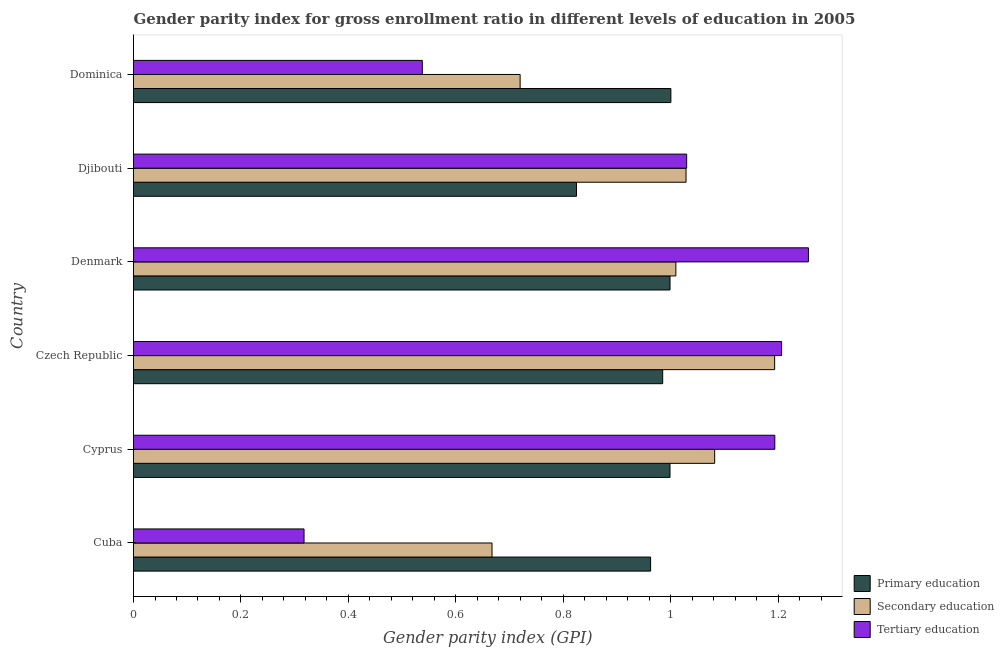How many groups of bars are there?
Make the answer very short. 6. Are the number of bars per tick equal to the number of legend labels?
Ensure brevity in your answer.  Yes. How many bars are there on the 2nd tick from the bottom?
Give a very brief answer. 3. What is the label of the 6th group of bars from the top?
Keep it short and to the point. Cuba. In how many cases, is the number of bars for a given country not equal to the number of legend labels?
Your answer should be very brief. 0. What is the gender parity index in tertiary education in Cyprus?
Provide a succinct answer. 1.19. Across all countries, what is the maximum gender parity index in tertiary education?
Your response must be concise. 1.26. Across all countries, what is the minimum gender parity index in tertiary education?
Ensure brevity in your answer.  0.32. In which country was the gender parity index in tertiary education minimum?
Provide a succinct answer. Cuba. What is the total gender parity index in tertiary education in the graph?
Ensure brevity in your answer.  5.54. What is the difference between the gender parity index in tertiary education in Czech Republic and that in Djibouti?
Your answer should be compact. 0.18. What is the difference between the gender parity index in primary education in Cuba and the gender parity index in tertiary education in Denmark?
Your answer should be very brief. -0.29. What is the difference between the gender parity index in tertiary education and gender parity index in primary education in Cuba?
Give a very brief answer. -0.65. In how many countries, is the gender parity index in primary education greater than 0.68 ?
Offer a very short reply. 6. What is the ratio of the gender parity index in tertiary education in Djibouti to that in Dominica?
Give a very brief answer. 1.92. Is the gender parity index in tertiary education in Denmark less than that in Djibouti?
Offer a very short reply. No. Is the difference between the gender parity index in primary education in Czech Republic and Denmark greater than the difference between the gender parity index in tertiary education in Czech Republic and Denmark?
Your response must be concise. Yes. What is the difference between the highest and the second highest gender parity index in secondary education?
Give a very brief answer. 0.11. What is the difference between the highest and the lowest gender parity index in primary education?
Offer a terse response. 0.18. In how many countries, is the gender parity index in tertiary education greater than the average gender parity index in tertiary education taken over all countries?
Make the answer very short. 4. Is the sum of the gender parity index in tertiary education in Czech Republic and Djibouti greater than the maximum gender parity index in secondary education across all countries?
Your response must be concise. Yes. What does the 1st bar from the top in Cuba represents?
Your response must be concise. Tertiary education. What does the 3rd bar from the bottom in Denmark represents?
Give a very brief answer. Tertiary education. Is it the case that in every country, the sum of the gender parity index in primary education and gender parity index in secondary education is greater than the gender parity index in tertiary education?
Your answer should be compact. Yes. Are all the bars in the graph horizontal?
Your response must be concise. Yes. Are the values on the major ticks of X-axis written in scientific E-notation?
Provide a succinct answer. No. Does the graph contain any zero values?
Ensure brevity in your answer.  No. How are the legend labels stacked?
Provide a succinct answer. Vertical. What is the title of the graph?
Your response must be concise. Gender parity index for gross enrollment ratio in different levels of education in 2005. What is the label or title of the X-axis?
Offer a very short reply. Gender parity index (GPI). What is the label or title of the Y-axis?
Offer a terse response. Country. What is the Gender parity index (GPI) of Primary education in Cuba?
Offer a very short reply. 0.96. What is the Gender parity index (GPI) in Secondary education in Cuba?
Ensure brevity in your answer.  0.67. What is the Gender parity index (GPI) in Tertiary education in Cuba?
Ensure brevity in your answer.  0.32. What is the Gender parity index (GPI) of Primary education in Cyprus?
Provide a succinct answer. 1. What is the Gender parity index (GPI) of Secondary education in Cyprus?
Your answer should be compact. 1.08. What is the Gender parity index (GPI) of Tertiary education in Cyprus?
Provide a short and direct response. 1.19. What is the Gender parity index (GPI) in Primary education in Czech Republic?
Provide a succinct answer. 0.99. What is the Gender parity index (GPI) in Secondary education in Czech Republic?
Keep it short and to the point. 1.19. What is the Gender parity index (GPI) in Tertiary education in Czech Republic?
Your answer should be very brief. 1.21. What is the Gender parity index (GPI) of Primary education in Denmark?
Your response must be concise. 1. What is the Gender parity index (GPI) of Secondary education in Denmark?
Your response must be concise. 1.01. What is the Gender parity index (GPI) in Tertiary education in Denmark?
Keep it short and to the point. 1.26. What is the Gender parity index (GPI) of Primary education in Djibouti?
Your response must be concise. 0.82. What is the Gender parity index (GPI) in Secondary education in Djibouti?
Give a very brief answer. 1.03. What is the Gender parity index (GPI) of Tertiary education in Djibouti?
Your answer should be compact. 1.03. What is the Gender parity index (GPI) of Primary education in Dominica?
Your response must be concise. 1. What is the Gender parity index (GPI) in Secondary education in Dominica?
Offer a terse response. 0.72. What is the Gender parity index (GPI) of Tertiary education in Dominica?
Offer a terse response. 0.54. Across all countries, what is the maximum Gender parity index (GPI) of Primary education?
Offer a very short reply. 1. Across all countries, what is the maximum Gender parity index (GPI) in Secondary education?
Your answer should be very brief. 1.19. Across all countries, what is the maximum Gender parity index (GPI) in Tertiary education?
Your answer should be compact. 1.26. Across all countries, what is the minimum Gender parity index (GPI) of Primary education?
Your answer should be very brief. 0.82. Across all countries, what is the minimum Gender parity index (GPI) of Secondary education?
Provide a short and direct response. 0.67. Across all countries, what is the minimum Gender parity index (GPI) in Tertiary education?
Offer a terse response. 0.32. What is the total Gender parity index (GPI) in Primary education in the graph?
Your response must be concise. 5.77. What is the total Gender parity index (GPI) of Secondary education in the graph?
Keep it short and to the point. 5.7. What is the total Gender parity index (GPI) in Tertiary education in the graph?
Give a very brief answer. 5.54. What is the difference between the Gender parity index (GPI) of Primary education in Cuba and that in Cyprus?
Provide a short and direct response. -0.04. What is the difference between the Gender parity index (GPI) in Secondary education in Cuba and that in Cyprus?
Offer a terse response. -0.41. What is the difference between the Gender parity index (GPI) of Tertiary education in Cuba and that in Cyprus?
Your answer should be compact. -0.88. What is the difference between the Gender parity index (GPI) of Primary education in Cuba and that in Czech Republic?
Provide a short and direct response. -0.02. What is the difference between the Gender parity index (GPI) of Secondary education in Cuba and that in Czech Republic?
Make the answer very short. -0.53. What is the difference between the Gender parity index (GPI) in Tertiary education in Cuba and that in Czech Republic?
Keep it short and to the point. -0.89. What is the difference between the Gender parity index (GPI) in Primary education in Cuba and that in Denmark?
Offer a terse response. -0.04. What is the difference between the Gender parity index (GPI) of Secondary education in Cuba and that in Denmark?
Your response must be concise. -0.34. What is the difference between the Gender parity index (GPI) of Tertiary education in Cuba and that in Denmark?
Provide a succinct answer. -0.94. What is the difference between the Gender parity index (GPI) of Primary education in Cuba and that in Djibouti?
Give a very brief answer. 0.14. What is the difference between the Gender parity index (GPI) of Secondary education in Cuba and that in Djibouti?
Offer a terse response. -0.36. What is the difference between the Gender parity index (GPI) of Tertiary education in Cuba and that in Djibouti?
Ensure brevity in your answer.  -0.71. What is the difference between the Gender parity index (GPI) in Primary education in Cuba and that in Dominica?
Keep it short and to the point. -0.04. What is the difference between the Gender parity index (GPI) in Secondary education in Cuba and that in Dominica?
Your answer should be very brief. -0.05. What is the difference between the Gender parity index (GPI) in Tertiary education in Cuba and that in Dominica?
Offer a terse response. -0.22. What is the difference between the Gender parity index (GPI) of Primary education in Cyprus and that in Czech Republic?
Make the answer very short. 0.01. What is the difference between the Gender parity index (GPI) of Secondary education in Cyprus and that in Czech Republic?
Make the answer very short. -0.11. What is the difference between the Gender parity index (GPI) of Tertiary education in Cyprus and that in Czech Republic?
Keep it short and to the point. -0.01. What is the difference between the Gender parity index (GPI) of Primary education in Cyprus and that in Denmark?
Ensure brevity in your answer.  -0. What is the difference between the Gender parity index (GPI) in Secondary education in Cyprus and that in Denmark?
Offer a very short reply. 0.07. What is the difference between the Gender parity index (GPI) of Tertiary education in Cyprus and that in Denmark?
Your answer should be very brief. -0.06. What is the difference between the Gender parity index (GPI) in Primary education in Cyprus and that in Djibouti?
Your response must be concise. 0.17. What is the difference between the Gender parity index (GPI) in Secondary education in Cyprus and that in Djibouti?
Keep it short and to the point. 0.05. What is the difference between the Gender parity index (GPI) of Tertiary education in Cyprus and that in Djibouti?
Offer a terse response. 0.16. What is the difference between the Gender parity index (GPI) in Primary education in Cyprus and that in Dominica?
Your answer should be very brief. -0. What is the difference between the Gender parity index (GPI) of Secondary education in Cyprus and that in Dominica?
Ensure brevity in your answer.  0.36. What is the difference between the Gender parity index (GPI) of Tertiary education in Cyprus and that in Dominica?
Give a very brief answer. 0.66. What is the difference between the Gender parity index (GPI) of Primary education in Czech Republic and that in Denmark?
Ensure brevity in your answer.  -0.01. What is the difference between the Gender parity index (GPI) in Secondary education in Czech Republic and that in Denmark?
Ensure brevity in your answer.  0.18. What is the difference between the Gender parity index (GPI) in Tertiary education in Czech Republic and that in Denmark?
Give a very brief answer. -0.05. What is the difference between the Gender parity index (GPI) of Primary education in Czech Republic and that in Djibouti?
Ensure brevity in your answer.  0.16. What is the difference between the Gender parity index (GPI) in Secondary education in Czech Republic and that in Djibouti?
Provide a succinct answer. 0.17. What is the difference between the Gender parity index (GPI) of Tertiary education in Czech Republic and that in Djibouti?
Your answer should be compact. 0.18. What is the difference between the Gender parity index (GPI) in Primary education in Czech Republic and that in Dominica?
Ensure brevity in your answer.  -0.02. What is the difference between the Gender parity index (GPI) of Secondary education in Czech Republic and that in Dominica?
Your answer should be compact. 0.47. What is the difference between the Gender parity index (GPI) of Tertiary education in Czech Republic and that in Dominica?
Your answer should be compact. 0.67. What is the difference between the Gender parity index (GPI) in Primary education in Denmark and that in Djibouti?
Your answer should be very brief. 0.17. What is the difference between the Gender parity index (GPI) in Secondary education in Denmark and that in Djibouti?
Provide a short and direct response. -0.02. What is the difference between the Gender parity index (GPI) in Tertiary education in Denmark and that in Djibouti?
Give a very brief answer. 0.23. What is the difference between the Gender parity index (GPI) in Primary education in Denmark and that in Dominica?
Provide a short and direct response. -0. What is the difference between the Gender parity index (GPI) of Secondary education in Denmark and that in Dominica?
Offer a very short reply. 0.29. What is the difference between the Gender parity index (GPI) in Tertiary education in Denmark and that in Dominica?
Offer a terse response. 0.72. What is the difference between the Gender parity index (GPI) of Primary education in Djibouti and that in Dominica?
Provide a short and direct response. -0.18. What is the difference between the Gender parity index (GPI) in Secondary education in Djibouti and that in Dominica?
Offer a very short reply. 0.31. What is the difference between the Gender parity index (GPI) in Tertiary education in Djibouti and that in Dominica?
Offer a very short reply. 0.49. What is the difference between the Gender parity index (GPI) of Primary education in Cuba and the Gender parity index (GPI) of Secondary education in Cyprus?
Offer a very short reply. -0.12. What is the difference between the Gender parity index (GPI) of Primary education in Cuba and the Gender parity index (GPI) of Tertiary education in Cyprus?
Keep it short and to the point. -0.23. What is the difference between the Gender parity index (GPI) in Secondary education in Cuba and the Gender parity index (GPI) in Tertiary education in Cyprus?
Your answer should be very brief. -0.53. What is the difference between the Gender parity index (GPI) of Primary education in Cuba and the Gender parity index (GPI) of Secondary education in Czech Republic?
Provide a succinct answer. -0.23. What is the difference between the Gender parity index (GPI) in Primary education in Cuba and the Gender parity index (GPI) in Tertiary education in Czech Republic?
Give a very brief answer. -0.24. What is the difference between the Gender parity index (GPI) in Secondary education in Cuba and the Gender parity index (GPI) in Tertiary education in Czech Republic?
Keep it short and to the point. -0.54. What is the difference between the Gender parity index (GPI) of Primary education in Cuba and the Gender parity index (GPI) of Secondary education in Denmark?
Make the answer very short. -0.05. What is the difference between the Gender parity index (GPI) of Primary education in Cuba and the Gender parity index (GPI) of Tertiary education in Denmark?
Give a very brief answer. -0.29. What is the difference between the Gender parity index (GPI) in Secondary education in Cuba and the Gender parity index (GPI) in Tertiary education in Denmark?
Ensure brevity in your answer.  -0.59. What is the difference between the Gender parity index (GPI) in Primary education in Cuba and the Gender parity index (GPI) in Secondary education in Djibouti?
Give a very brief answer. -0.07. What is the difference between the Gender parity index (GPI) of Primary education in Cuba and the Gender parity index (GPI) of Tertiary education in Djibouti?
Keep it short and to the point. -0.07. What is the difference between the Gender parity index (GPI) in Secondary education in Cuba and the Gender parity index (GPI) in Tertiary education in Djibouti?
Keep it short and to the point. -0.36. What is the difference between the Gender parity index (GPI) of Primary education in Cuba and the Gender parity index (GPI) of Secondary education in Dominica?
Provide a succinct answer. 0.24. What is the difference between the Gender parity index (GPI) in Primary education in Cuba and the Gender parity index (GPI) in Tertiary education in Dominica?
Your answer should be very brief. 0.42. What is the difference between the Gender parity index (GPI) of Secondary education in Cuba and the Gender parity index (GPI) of Tertiary education in Dominica?
Offer a terse response. 0.13. What is the difference between the Gender parity index (GPI) in Primary education in Cyprus and the Gender parity index (GPI) in Secondary education in Czech Republic?
Give a very brief answer. -0.19. What is the difference between the Gender parity index (GPI) of Primary education in Cyprus and the Gender parity index (GPI) of Tertiary education in Czech Republic?
Your answer should be very brief. -0.21. What is the difference between the Gender parity index (GPI) in Secondary education in Cyprus and the Gender parity index (GPI) in Tertiary education in Czech Republic?
Keep it short and to the point. -0.12. What is the difference between the Gender parity index (GPI) in Primary education in Cyprus and the Gender parity index (GPI) in Secondary education in Denmark?
Offer a terse response. -0.01. What is the difference between the Gender parity index (GPI) of Primary education in Cyprus and the Gender parity index (GPI) of Tertiary education in Denmark?
Your answer should be very brief. -0.26. What is the difference between the Gender parity index (GPI) in Secondary education in Cyprus and the Gender parity index (GPI) in Tertiary education in Denmark?
Your answer should be very brief. -0.17. What is the difference between the Gender parity index (GPI) in Primary education in Cyprus and the Gender parity index (GPI) in Secondary education in Djibouti?
Your answer should be very brief. -0.03. What is the difference between the Gender parity index (GPI) of Primary education in Cyprus and the Gender parity index (GPI) of Tertiary education in Djibouti?
Offer a very short reply. -0.03. What is the difference between the Gender parity index (GPI) of Secondary education in Cyprus and the Gender parity index (GPI) of Tertiary education in Djibouti?
Keep it short and to the point. 0.05. What is the difference between the Gender parity index (GPI) of Primary education in Cyprus and the Gender parity index (GPI) of Secondary education in Dominica?
Make the answer very short. 0.28. What is the difference between the Gender parity index (GPI) of Primary education in Cyprus and the Gender parity index (GPI) of Tertiary education in Dominica?
Make the answer very short. 0.46. What is the difference between the Gender parity index (GPI) of Secondary education in Cyprus and the Gender parity index (GPI) of Tertiary education in Dominica?
Your answer should be compact. 0.54. What is the difference between the Gender parity index (GPI) in Primary education in Czech Republic and the Gender parity index (GPI) in Secondary education in Denmark?
Make the answer very short. -0.02. What is the difference between the Gender parity index (GPI) in Primary education in Czech Republic and the Gender parity index (GPI) in Tertiary education in Denmark?
Provide a succinct answer. -0.27. What is the difference between the Gender parity index (GPI) in Secondary education in Czech Republic and the Gender parity index (GPI) in Tertiary education in Denmark?
Offer a very short reply. -0.06. What is the difference between the Gender parity index (GPI) of Primary education in Czech Republic and the Gender parity index (GPI) of Secondary education in Djibouti?
Your answer should be very brief. -0.04. What is the difference between the Gender parity index (GPI) of Primary education in Czech Republic and the Gender parity index (GPI) of Tertiary education in Djibouti?
Provide a succinct answer. -0.04. What is the difference between the Gender parity index (GPI) in Secondary education in Czech Republic and the Gender parity index (GPI) in Tertiary education in Djibouti?
Provide a succinct answer. 0.16. What is the difference between the Gender parity index (GPI) of Primary education in Czech Republic and the Gender parity index (GPI) of Secondary education in Dominica?
Your answer should be compact. 0.27. What is the difference between the Gender parity index (GPI) in Primary education in Czech Republic and the Gender parity index (GPI) in Tertiary education in Dominica?
Ensure brevity in your answer.  0.45. What is the difference between the Gender parity index (GPI) of Secondary education in Czech Republic and the Gender parity index (GPI) of Tertiary education in Dominica?
Provide a succinct answer. 0.66. What is the difference between the Gender parity index (GPI) of Primary education in Denmark and the Gender parity index (GPI) of Secondary education in Djibouti?
Keep it short and to the point. -0.03. What is the difference between the Gender parity index (GPI) in Primary education in Denmark and the Gender parity index (GPI) in Tertiary education in Djibouti?
Your answer should be compact. -0.03. What is the difference between the Gender parity index (GPI) in Secondary education in Denmark and the Gender parity index (GPI) in Tertiary education in Djibouti?
Your answer should be very brief. -0.02. What is the difference between the Gender parity index (GPI) of Primary education in Denmark and the Gender parity index (GPI) of Secondary education in Dominica?
Your answer should be compact. 0.28. What is the difference between the Gender parity index (GPI) of Primary education in Denmark and the Gender parity index (GPI) of Tertiary education in Dominica?
Make the answer very short. 0.46. What is the difference between the Gender parity index (GPI) in Secondary education in Denmark and the Gender parity index (GPI) in Tertiary education in Dominica?
Your response must be concise. 0.47. What is the difference between the Gender parity index (GPI) of Primary education in Djibouti and the Gender parity index (GPI) of Secondary education in Dominica?
Give a very brief answer. 0.1. What is the difference between the Gender parity index (GPI) of Primary education in Djibouti and the Gender parity index (GPI) of Tertiary education in Dominica?
Your answer should be very brief. 0.29. What is the difference between the Gender parity index (GPI) in Secondary education in Djibouti and the Gender parity index (GPI) in Tertiary education in Dominica?
Keep it short and to the point. 0.49. What is the average Gender parity index (GPI) of Primary education per country?
Make the answer very short. 0.96. What is the average Gender parity index (GPI) in Secondary education per country?
Provide a short and direct response. 0.95. What is the average Gender parity index (GPI) in Tertiary education per country?
Keep it short and to the point. 0.92. What is the difference between the Gender parity index (GPI) of Primary education and Gender parity index (GPI) of Secondary education in Cuba?
Your answer should be compact. 0.3. What is the difference between the Gender parity index (GPI) of Primary education and Gender parity index (GPI) of Tertiary education in Cuba?
Offer a very short reply. 0.65. What is the difference between the Gender parity index (GPI) of Secondary education and Gender parity index (GPI) of Tertiary education in Cuba?
Your response must be concise. 0.35. What is the difference between the Gender parity index (GPI) in Primary education and Gender parity index (GPI) in Secondary education in Cyprus?
Make the answer very short. -0.08. What is the difference between the Gender parity index (GPI) in Primary education and Gender parity index (GPI) in Tertiary education in Cyprus?
Offer a very short reply. -0.2. What is the difference between the Gender parity index (GPI) of Secondary education and Gender parity index (GPI) of Tertiary education in Cyprus?
Give a very brief answer. -0.11. What is the difference between the Gender parity index (GPI) of Primary education and Gender parity index (GPI) of Secondary education in Czech Republic?
Ensure brevity in your answer.  -0.21. What is the difference between the Gender parity index (GPI) of Primary education and Gender parity index (GPI) of Tertiary education in Czech Republic?
Give a very brief answer. -0.22. What is the difference between the Gender parity index (GPI) in Secondary education and Gender parity index (GPI) in Tertiary education in Czech Republic?
Your answer should be very brief. -0.01. What is the difference between the Gender parity index (GPI) of Primary education and Gender parity index (GPI) of Secondary education in Denmark?
Your answer should be very brief. -0.01. What is the difference between the Gender parity index (GPI) of Primary education and Gender parity index (GPI) of Tertiary education in Denmark?
Provide a succinct answer. -0.26. What is the difference between the Gender parity index (GPI) in Secondary education and Gender parity index (GPI) in Tertiary education in Denmark?
Keep it short and to the point. -0.25. What is the difference between the Gender parity index (GPI) of Primary education and Gender parity index (GPI) of Secondary education in Djibouti?
Provide a succinct answer. -0.2. What is the difference between the Gender parity index (GPI) of Primary education and Gender parity index (GPI) of Tertiary education in Djibouti?
Make the answer very short. -0.21. What is the difference between the Gender parity index (GPI) in Secondary education and Gender parity index (GPI) in Tertiary education in Djibouti?
Provide a succinct answer. -0. What is the difference between the Gender parity index (GPI) in Primary education and Gender parity index (GPI) in Secondary education in Dominica?
Provide a short and direct response. 0.28. What is the difference between the Gender parity index (GPI) in Primary education and Gender parity index (GPI) in Tertiary education in Dominica?
Keep it short and to the point. 0.46. What is the difference between the Gender parity index (GPI) of Secondary education and Gender parity index (GPI) of Tertiary education in Dominica?
Ensure brevity in your answer.  0.18. What is the ratio of the Gender parity index (GPI) of Primary education in Cuba to that in Cyprus?
Your answer should be compact. 0.96. What is the ratio of the Gender parity index (GPI) of Secondary education in Cuba to that in Cyprus?
Give a very brief answer. 0.62. What is the ratio of the Gender parity index (GPI) of Tertiary education in Cuba to that in Cyprus?
Your response must be concise. 0.27. What is the ratio of the Gender parity index (GPI) in Primary education in Cuba to that in Czech Republic?
Offer a terse response. 0.98. What is the ratio of the Gender parity index (GPI) in Secondary education in Cuba to that in Czech Republic?
Your answer should be very brief. 0.56. What is the ratio of the Gender parity index (GPI) in Tertiary education in Cuba to that in Czech Republic?
Give a very brief answer. 0.26. What is the ratio of the Gender parity index (GPI) in Primary education in Cuba to that in Denmark?
Make the answer very short. 0.96. What is the ratio of the Gender parity index (GPI) in Secondary education in Cuba to that in Denmark?
Your answer should be very brief. 0.66. What is the ratio of the Gender parity index (GPI) of Tertiary education in Cuba to that in Denmark?
Provide a succinct answer. 0.25. What is the ratio of the Gender parity index (GPI) in Primary education in Cuba to that in Djibouti?
Provide a short and direct response. 1.17. What is the ratio of the Gender parity index (GPI) in Secondary education in Cuba to that in Djibouti?
Offer a terse response. 0.65. What is the ratio of the Gender parity index (GPI) in Tertiary education in Cuba to that in Djibouti?
Keep it short and to the point. 0.31. What is the ratio of the Gender parity index (GPI) of Primary education in Cuba to that in Dominica?
Provide a succinct answer. 0.96. What is the ratio of the Gender parity index (GPI) of Secondary education in Cuba to that in Dominica?
Make the answer very short. 0.93. What is the ratio of the Gender parity index (GPI) of Tertiary education in Cuba to that in Dominica?
Ensure brevity in your answer.  0.59. What is the ratio of the Gender parity index (GPI) of Primary education in Cyprus to that in Czech Republic?
Provide a succinct answer. 1.01. What is the ratio of the Gender parity index (GPI) of Secondary education in Cyprus to that in Czech Republic?
Ensure brevity in your answer.  0.91. What is the ratio of the Gender parity index (GPI) in Tertiary education in Cyprus to that in Czech Republic?
Give a very brief answer. 0.99. What is the ratio of the Gender parity index (GPI) of Secondary education in Cyprus to that in Denmark?
Offer a very short reply. 1.07. What is the ratio of the Gender parity index (GPI) of Tertiary education in Cyprus to that in Denmark?
Offer a terse response. 0.95. What is the ratio of the Gender parity index (GPI) in Primary education in Cyprus to that in Djibouti?
Your answer should be compact. 1.21. What is the ratio of the Gender parity index (GPI) in Secondary education in Cyprus to that in Djibouti?
Ensure brevity in your answer.  1.05. What is the ratio of the Gender parity index (GPI) in Tertiary education in Cyprus to that in Djibouti?
Give a very brief answer. 1.16. What is the ratio of the Gender parity index (GPI) of Primary education in Cyprus to that in Dominica?
Your response must be concise. 1. What is the ratio of the Gender parity index (GPI) of Secondary education in Cyprus to that in Dominica?
Make the answer very short. 1.5. What is the ratio of the Gender parity index (GPI) of Tertiary education in Cyprus to that in Dominica?
Make the answer very short. 2.22. What is the ratio of the Gender parity index (GPI) of Primary education in Czech Republic to that in Denmark?
Your answer should be compact. 0.99. What is the ratio of the Gender parity index (GPI) of Secondary education in Czech Republic to that in Denmark?
Offer a very short reply. 1.18. What is the ratio of the Gender parity index (GPI) of Tertiary education in Czech Republic to that in Denmark?
Offer a very short reply. 0.96. What is the ratio of the Gender parity index (GPI) of Primary education in Czech Republic to that in Djibouti?
Give a very brief answer. 1.19. What is the ratio of the Gender parity index (GPI) of Secondary education in Czech Republic to that in Djibouti?
Provide a short and direct response. 1.16. What is the ratio of the Gender parity index (GPI) of Tertiary education in Czech Republic to that in Djibouti?
Offer a terse response. 1.17. What is the ratio of the Gender parity index (GPI) of Secondary education in Czech Republic to that in Dominica?
Your answer should be compact. 1.66. What is the ratio of the Gender parity index (GPI) of Tertiary education in Czech Republic to that in Dominica?
Keep it short and to the point. 2.24. What is the ratio of the Gender parity index (GPI) of Primary education in Denmark to that in Djibouti?
Make the answer very short. 1.21. What is the ratio of the Gender parity index (GPI) of Secondary education in Denmark to that in Djibouti?
Your answer should be very brief. 0.98. What is the ratio of the Gender parity index (GPI) in Tertiary education in Denmark to that in Djibouti?
Make the answer very short. 1.22. What is the ratio of the Gender parity index (GPI) in Secondary education in Denmark to that in Dominica?
Offer a very short reply. 1.4. What is the ratio of the Gender parity index (GPI) in Tertiary education in Denmark to that in Dominica?
Offer a terse response. 2.34. What is the ratio of the Gender parity index (GPI) in Primary education in Djibouti to that in Dominica?
Offer a very short reply. 0.82. What is the ratio of the Gender parity index (GPI) in Secondary education in Djibouti to that in Dominica?
Offer a terse response. 1.43. What is the ratio of the Gender parity index (GPI) in Tertiary education in Djibouti to that in Dominica?
Make the answer very short. 1.92. What is the difference between the highest and the second highest Gender parity index (GPI) of Primary education?
Ensure brevity in your answer.  0. What is the difference between the highest and the second highest Gender parity index (GPI) of Secondary education?
Ensure brevity in your answer.  0.11. What is the difference between the highest and the lowest Gender parity index (GPI) in Primary education?
Give a very brief answer. 0.18. What is the difference between the highest and the lowest Gender parity index (GPI) in Secondary education?
Give a very brief answer. 0.53. What is the difference between the highest and the lowest Gender parity index (GPI) in Tertiary education?
Give a very brief answer. 0.94. 